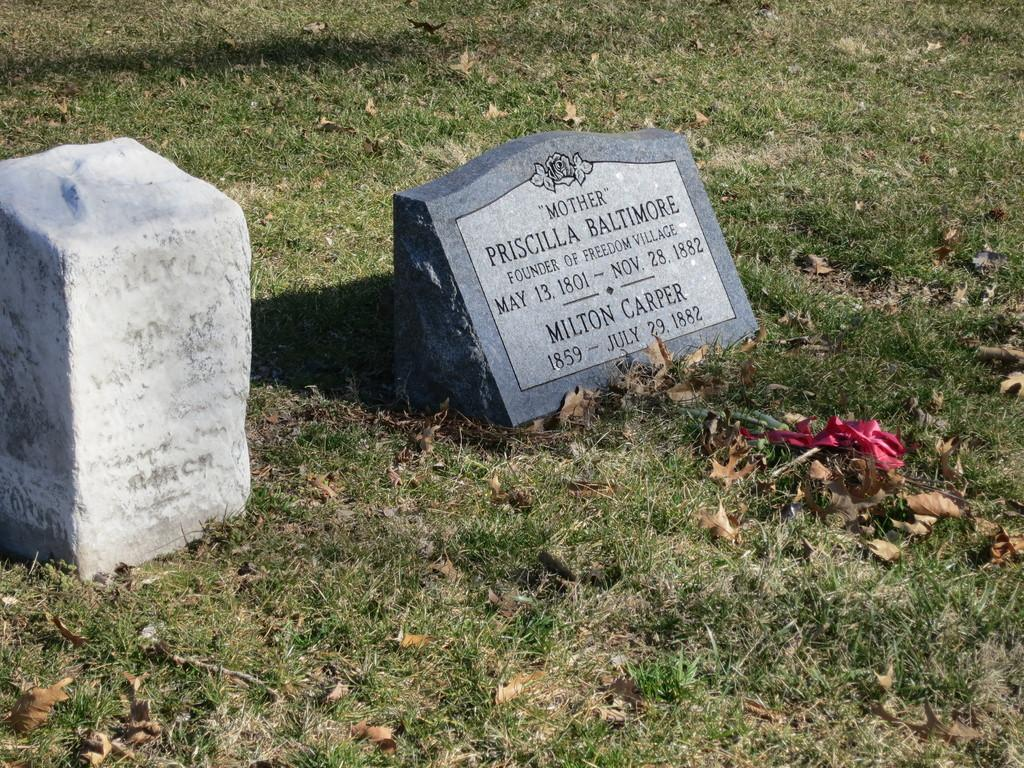What type of objects can be seen in the image? There are stones in the image. What is written or depicted on the stones? There is text on the stones. What type of vegetation is at the bottom of the image? There is grass at the bottom of the image. What else can be seen on the grass? Dried leaves are present on the grass. What type of sail can be seen on the stage in the image? There is no sail or stage present in the image; it features stones with text and grass with dried leaves. 